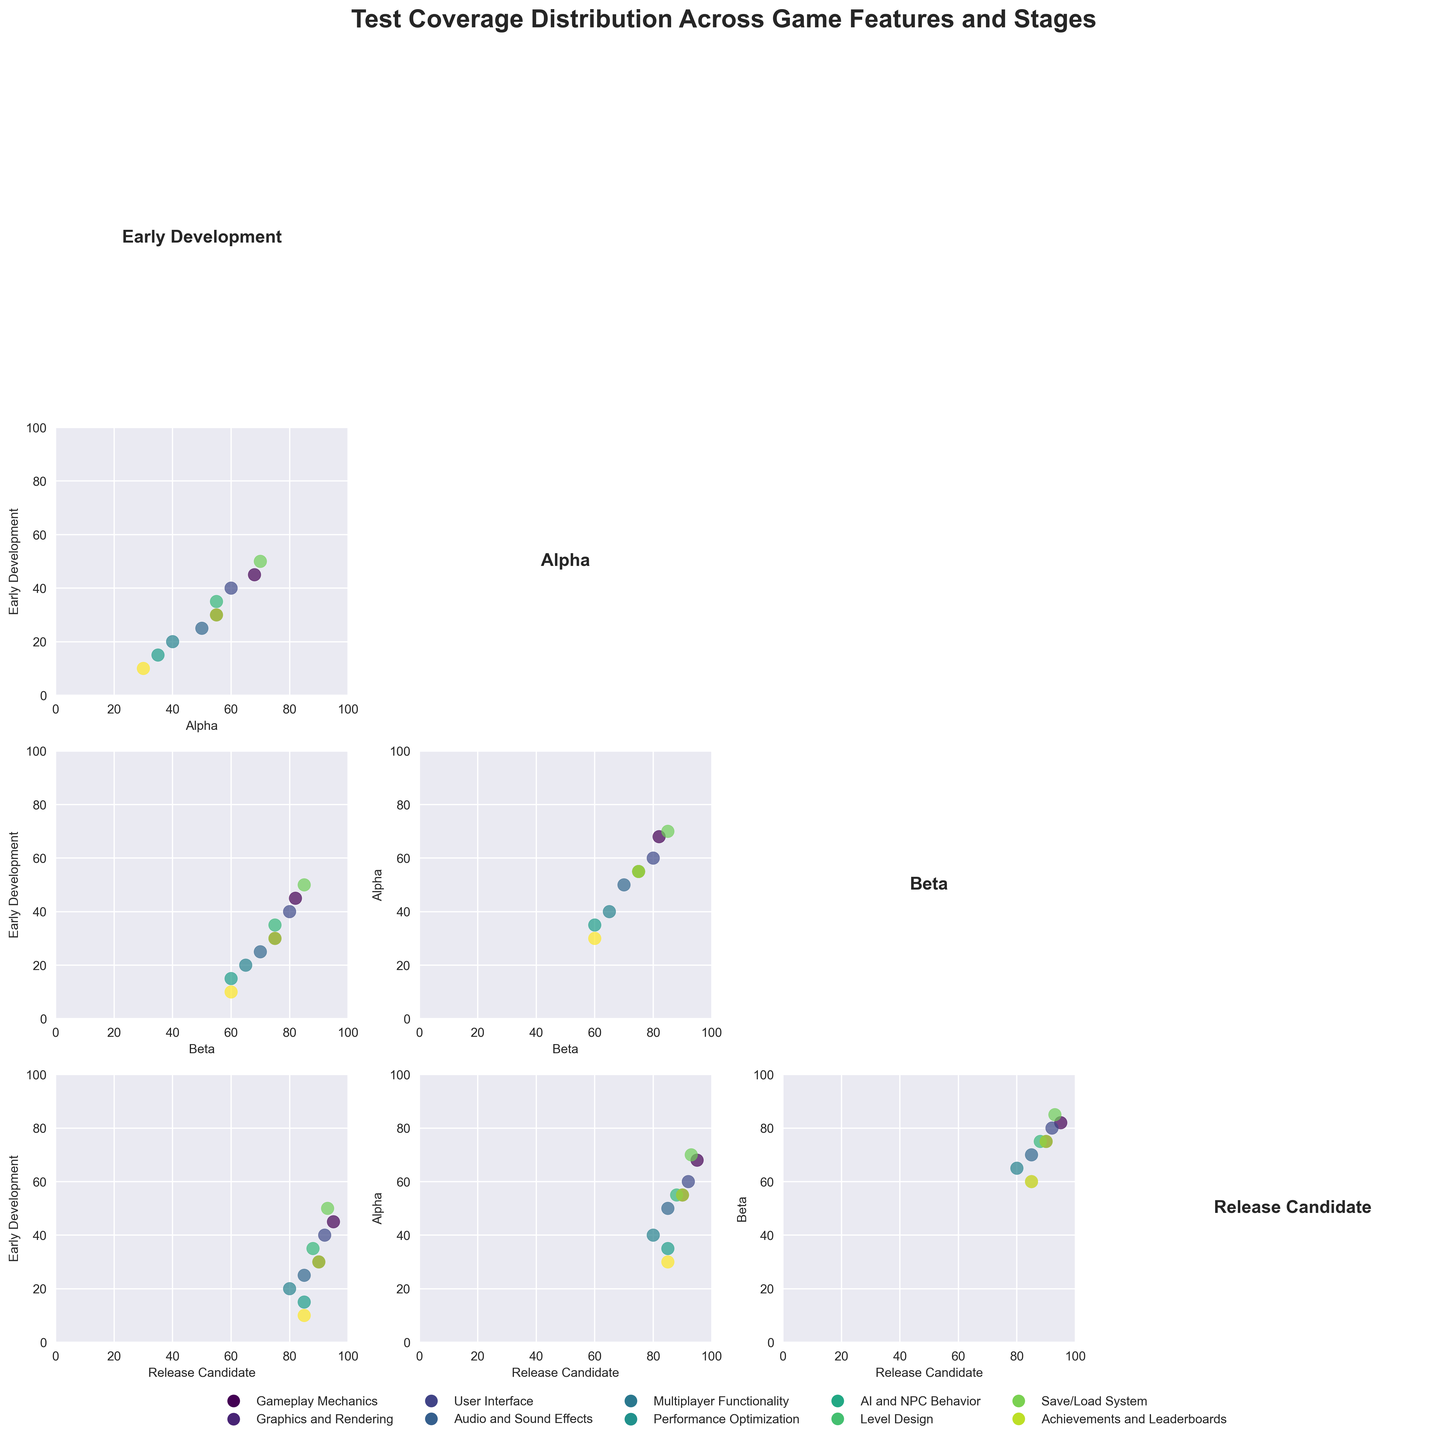What is the title of the plot? The title of a plot is typically found at the top of the figure and provides a summary of what the plot represents. In this case, the title is "Test Coverage Distribution Across Game Features and Stages," which indicates that the plot displays test coverage percentages across different game features and development stages.
Answer: Test Coverage Distribution Across Game Features and Stages What do the axes represent in the scatterplot matrix? In a scatterplot matrix, the axes for each scattered plot represent different variables. Here, each axis represents the test coverage percentage at different development stages: Early Development, Alpha, Beta, and Release Candidate.
Answer: Test coverage percentages at different development stages Which feature has the highest test coverage in the Early Development stage? To identify the highest test coverage percentage in the Early Development stage, look at the scatterplots involving the 'Early Development' axis and find the maximum value. The Feature corresponding to this value is 'Level Design' with a test coverage of 50%.
Answer: Level Design Comparing the Alpha and Beta stages, which game feature shows the biggest increase in test coverage? To determine the biggest increase in test coverage from Alpha to Beta, subtract the Alpha values from the Beta values for each feature. The feature with the largest difference is 'Performance Optimization', with an increase of 25% (60% - 35%).
Answer: Performance Optimization What is the color scheme used to distinguish different features in the scatterplot matrix? The scatterplot matrix uses a colormap to distinguish different features, typical in visualizations to differentiate data points based on categories. Here, a 'viridis' colormap is used, with each unique color representing a specific game feature.
Answer: 'viridis' colormap Is there a feature that has the same test coverage percentage in both the Beta and Release Candidate stages? If yes, which one? To find out if a feature has the same test coverage percentage in Beta and Release Candidate stages, compare the values in these two columns for all features. 'Multiplayer Functionality' has the same test coverage of 80% in both stages.
Answer: Multiplayer Functionality How does the test coverage percentage of 'Graphics and Rendering' change as the game progresses from Early Development to Release Candidate? To describe the change in test coverage for 'Graphics and Rendering', observe its value across stages: Early Development (30%), Alpha (55%), Beta (75%), and Release Candidate (90%). The coverage consistently increases across each stage.
Answer: Increases consistently What is the relationship between test coverage percentages in the Alpha stage and the Release Candidate stage? To understand the relationship, observe the scatterplot between the Alpha and Release Candidate stages. There's a visible positive correlation, indicating that higher test coverage in the Alpha stage generally leads to higher test coverage in the Release Candidate stage.
Answer: Positive correlation 